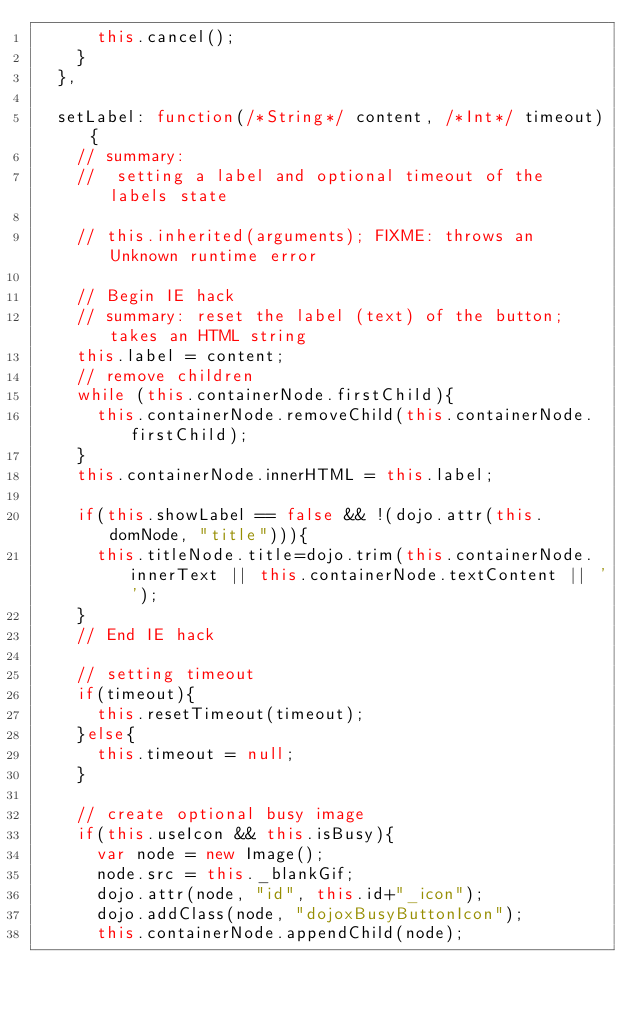<code> <loc_0><loc_0><loc_500><loc_500><_JavaScript_>			this.cancel();
		}
	},
	
	setLabel: function(/*String*/ content, /*Int*/ timeout){
		// summary:
		//	setting a label and optional timeout of the labels state
		
		// this.inherited(arguments); FIXME: throws an Unknown runtime error
		
		// Begin IE hack
		// summary: reset the label (text) of the button; takes an HTML string
		this.label = content;
		// remove children
		while (this.containerNode.firstChild){
			this.containerNode.removeChild(this.containerNode.firstChild);
		}
		this.containerNode.innerHTML = this.label;
		
		if(this.showLabel == false && !(dojo.attr(this.domNode, "title"))){
			this.titleNode.title=dojo.trim(this.containerNode.innerText || this.containerNode.textContent || '');
		}
		// End IE hack
		
		// setting timeout
		if(timeout){
			this.resetTimeout(timeout);
		}else{
			this.timeout = null;
		}
		
		// create optional busy image
		if(this.useIcon && this.isBusy){
			var node = new Image();
			node.src = this._blankGif;
			dojo.attr(node, "id", this.id+"_icon");
			dojo.addClass(node, "dojoxBusyButtonIcon");
			this.containerNode.appendChild(node);</code> 